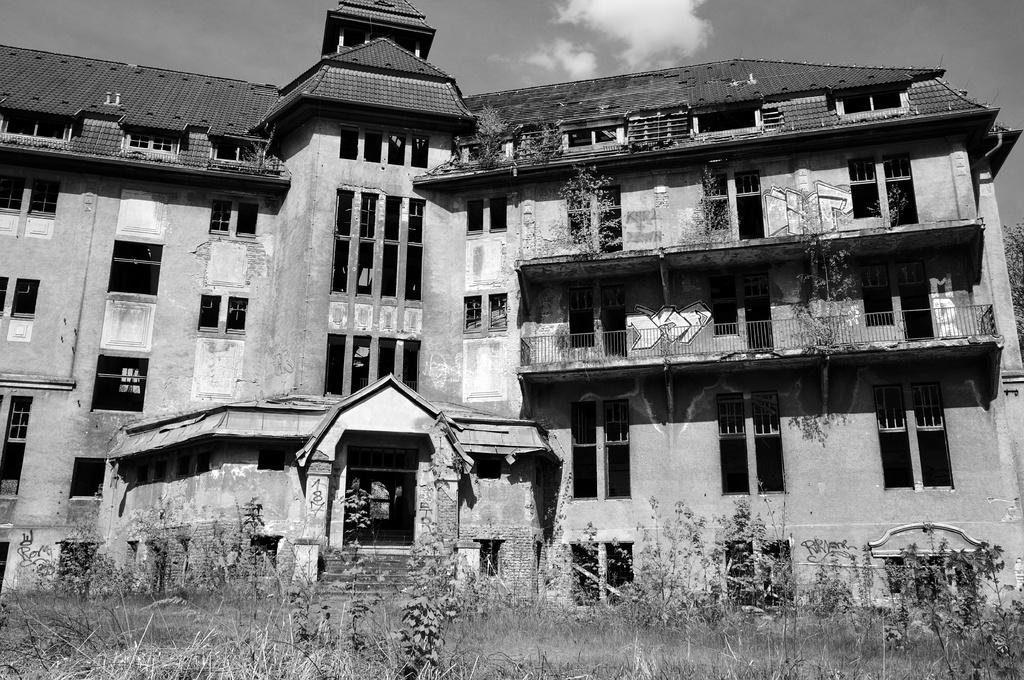What type of structure is visible in the image? There is a building in the image. What can be seen in the foreground of the image? There is a staircase and grass in the foreground of the image. What type of vegetation is present in the image? There are plants in the image. What is visible at the top of the image? The sky is visible at the top of the image. What can be seen in the sky? There are clouds in the sky. What type of chain is hanging from the building in the image? There is no chain visible in the image. Is there a stick used as a decoration in the image? There is no stick present in the image. 